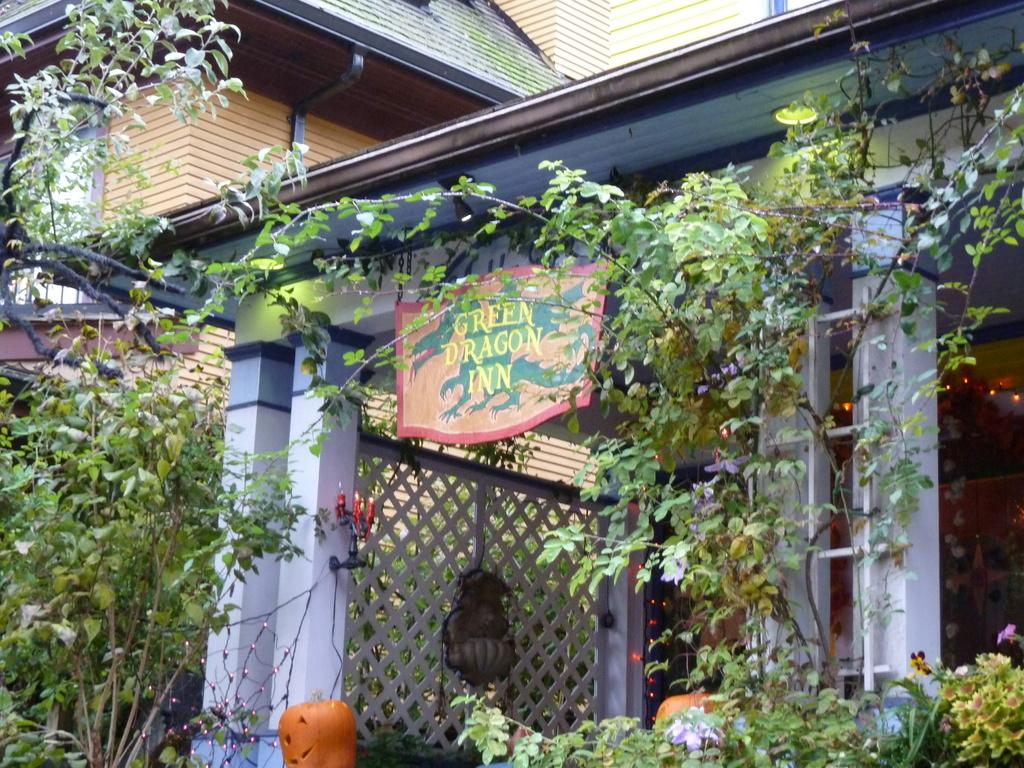What type of structure is in the image? There is a building in the image. What is on the entrance of the building? There is a board on the entrance of the building. What can be seen at the bottom of the image? Plants, flowers, and a pumpkin are visible at the bottom of the image. How many rooms are visible in the image? There is no information about rooms in the image; it only shows a building, a board, and elements at the bottom. Are there any horses present in the image? There are no horses visible in the image. 